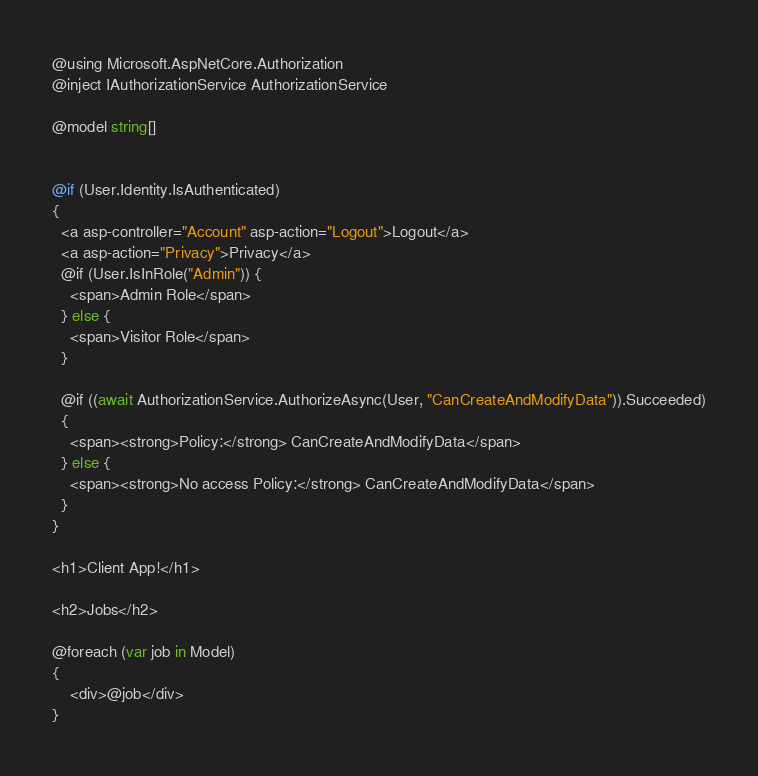Convert code to text. <code><loc_0><loc_0><loc_500><loc_500><_C#_>@using Microsoft.AspNetCore.Authorization
@inject IAuthorizationService AuthorizationService

@model string[]


@if (User.Identity.IsAuthenticated)
{
  <a asp-controller="Account" asp-action="Logout">Logout</a>
  <a asp-action="Privacy">Privacy</a>
  @if (User.IsInRole("Admin")) {
    <span>Admin Role</span>
  } else {
    <span>Visitor Role</span>
  }

  @if ((await AuthorizationService.AuthorizeAsync(User, "CanCreateAndModifyData")).Succeeded)
  {
    <span><strong>Policy:</strong> CanCreateAndModifyData</span>
  } else {
    <span><strong>No access Policy:</strong> CanCreateAndModifyData</span>
  }
}

<h1>Client App!</h1>

<h2>Jobs</h2>

@foreach (var job in Model)
{
    <div>@job</div>
}
</code> 